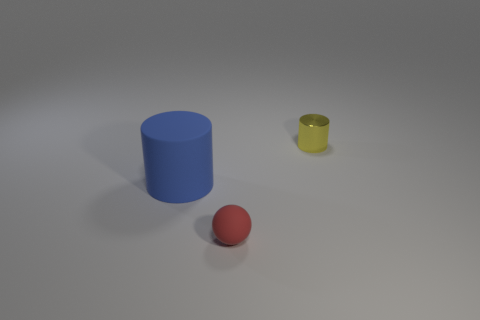Add 1 tiny red metal objects. How many objects exist? 4 Subtract all balls. How many objects are left? 2 Add 1 large metal cylinders. How many large metal cylinders exist? 1 Subtract 0 purple cylinders. How many objects are left? 3 Subtract all big green spheres. Subtract all blue things. How many objects are left? 2 Add 3 large blue rubber cylinders. How many large blue rubber cylinders are left? 4 